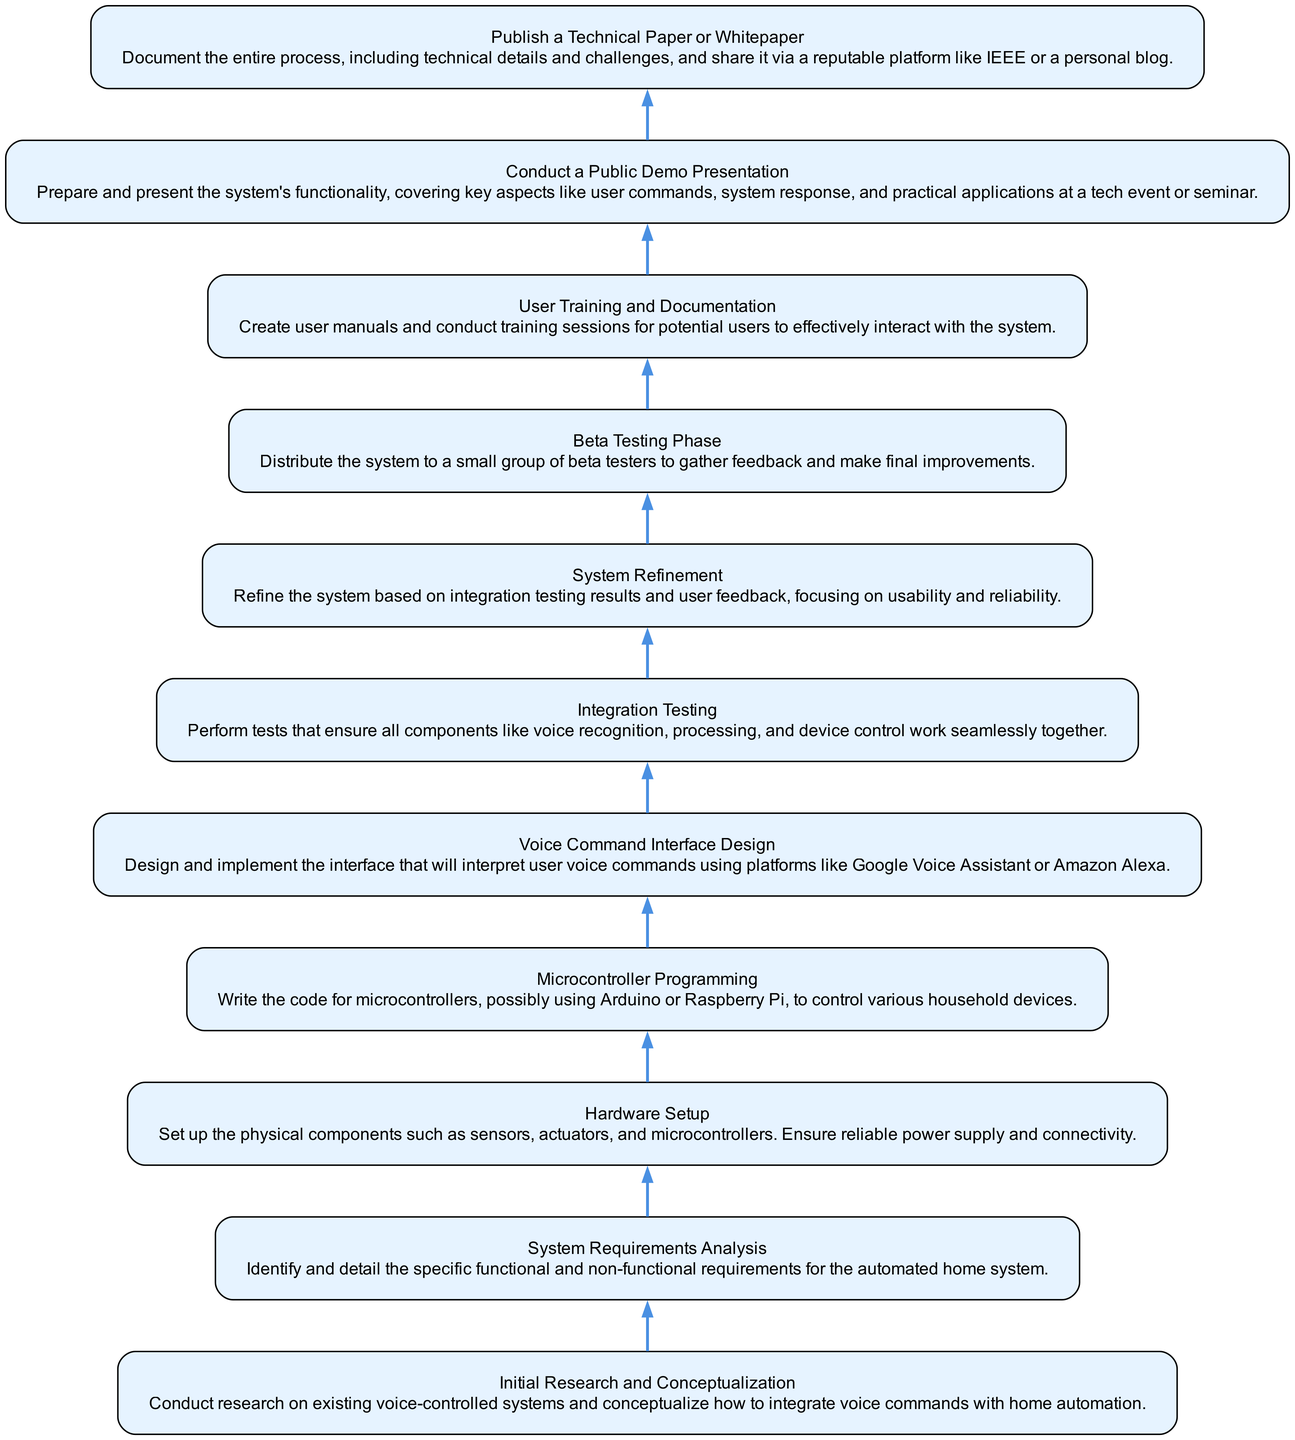What is the top node in the diagram? The top node in the diagram represents the ultimate goal of the project, which is to "Publish a Technical Paper or Whitepaper." This node is located at the very top of the flow chart.
Answer: Publish a Technical Paper or Whitepaper How many nodes are in the diagram? By counting each distinct element in the flow chart, there are a total of 11 nodes representing different stages in the development process.
Answer: 11 Which step comes directly before the public demo? The step that comes directly before the "Conduct a Public Demo Presentation" is "User Training and Documentation." Looking at the order in the flow chart, these nodes are sequential.
Answer: User Training and Documentation What is the main purpose of the Beta Testing Phase? The Beta Testing Phase focuses on gathering feedback from a small group of testers to make final improvements to the system. This purpose is indicated in the node's description.
Answer: Gather feedback What is the relationship between Integration Testing and System Refinement? Integration Testing is performed to ensure all components work seamlessly together, and based on its results, the "System Refinement" is carried out. This indicates a direct sequential relationship where the output of one step feeds into the next.
Answer: Integration Testing leads to System Refinement Which process immediately follows Microcontroller Programming? The process that immediately follows "Microcontroller Programming" in the flow is "Hardware Setup," which is depicted as the next step in the flow chart.
Answer: Hardware Setup How many steps are there between initial research and public demo? Counting the steps from "Initial Research and Conceptualization" to "Conduct a Public Demo Presentation," there are a total of 6 steps (including both the start and end nodes).
Answer: 6 What does the Voice Command Interface Design focus on? The Voice Command Interface Design focuses on interpreting user voice commands through platforms like Google Voice Assistant or Amazon Alexa. This is specified in the description of that node.
Answer: Interpreting voice commands What is the last step in the development process? The last step in the development process, as indicated in the flow chart, is "Publish a Technical Paper or Whitepaper." This marks the conclusion of the project's workflow.
Answer: Publish a Technical Paper or Whitepaper 